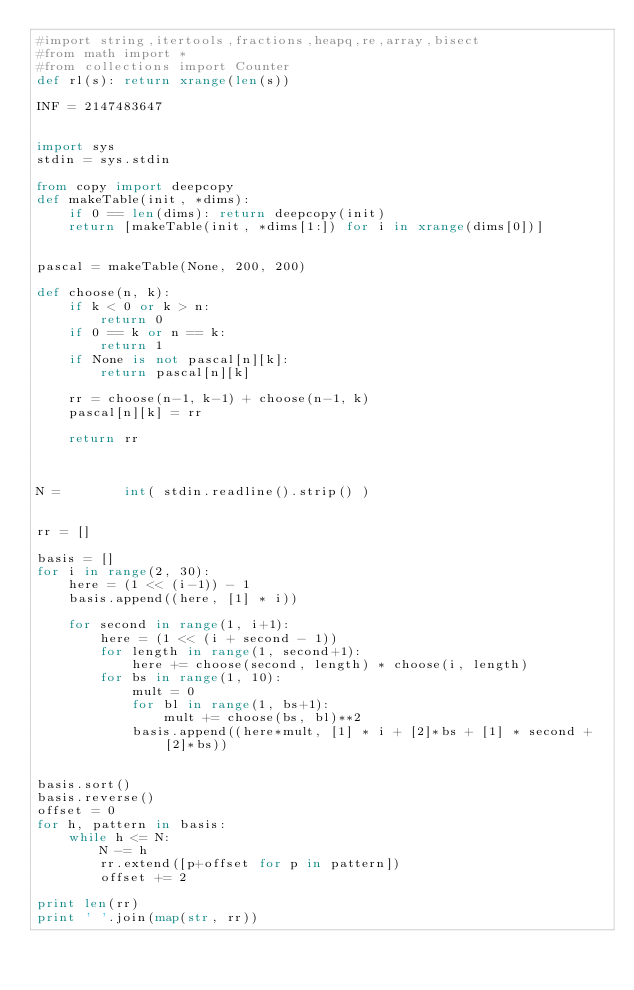Convert code to text. <code><loc_0><loc_0><loc_500><loc_500><_Python_>#import string,itertools,fractions,heapq,re,array,bisect
#from math import *
#from collections import Counter
def rl(s): return xrange(len(s))

INF = 2147483647


import sys
stdin = sys.stdin

from copy import deepcopy
def makeTable(init, *dims):
    if 0 == len(dims): return deepcopy(init)
    return [makeTable(init, *dims[1:]) for i in xrange(dims[0])]


pascal = makeTable(None, 200, 200)

def choose(n, k):
    if k < 0 or k > n:
        return 0
    if 0 == k or n == k:
        return 1
    if None is not pascal[n][k]:
        return pascal[n][k]

    rr = choose(n-1, k-1) + choose(n-1, k)
    pascal[n][k] = rr

    return rr



N =        int( stdin.readline().strip() )


rr = []

basis = []
for i in range(2, 30):
    here = (1 << (i-1)) - 1
    basis.append((here, [1] * i))

    for second in range(1, i+1):
        here = (1 << (i + second - 1))
        for length in range(1, second+1):
            here += choose(second, length) * choose(i, length)
        for bs in range(1, 10):
            mult = 0
            for bl in range(1, bs+1):
                mult += choose(bs, bl)**2
            basis.append((here*mult, [1] * i + [2]*bs + [1] * second + [2]*bs))


basis.sort()
basis.reverse()
offset = 0
for h, pattern in basis:
    while h <= N:
        N -= h
        rr.extend([p+offset for p in pattern])
        offset += 2

print len(rr)
print ' '.join(map(str, rr))
</code> 